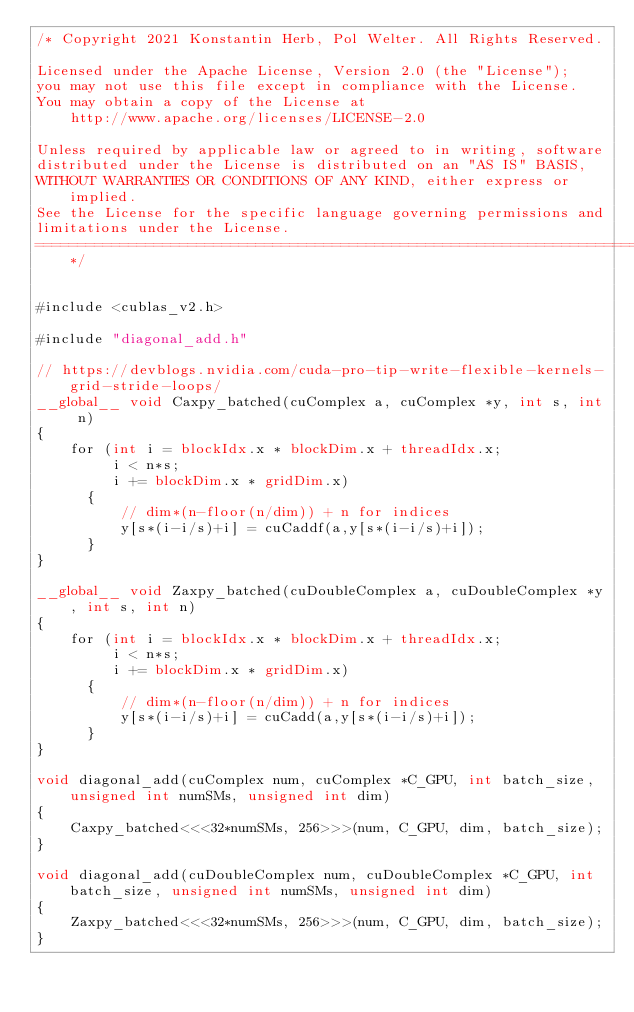Convert code to text. <code><loc_0><loc_0><loc_500><loc_500><_Cuda_>/* Copyright 2021 Konstantin Herb, Pol Welter. All Rights Reserved.

Licensed under the Apache License, Version 2.0 (the "License");
you may not use this file except in compliance with the License.
You may obtain a copy of the License at
    http://www.apache.org/licenses/LICENSE-2.0

Unless required by applicable law or agreed to in writing, software
distributed under the License is distributed on an "AS IS" BASIS,
WITHOUT WARRANTIES OR CONDITIONS OF ANY KIND, either express or implied.
See the License for the specific language governing permissions and
limitations under the License.
==============================================================================*/


#include <cublas_v2.h>

#include "diagonal_add.h"

// https://devblogs.nvidia.com/cuda-pro-tip-write-flexible-kernels-grid-stride-loops/
__global__ void Caxpy_batched(cuComplex a, cuComplex *y, int s, int n)
{
    for (int i = blockIdx.x * blockDim.x + threadIdx.x; 
         i < n*s; 
         i += blockDim.x * gridDim.x) 
      {
          // dim*(n-floor(n/dim)) + n for indices
          y[s*(i-i/s)+i] = cuCaddf(a,y[s*(i-i/s)+i]);
      }
}

__global__ void Zaxpy_batched(cuDoubleComplex a, cuDoubleComplex *y, int s, int n)
{
    for (int i = blockIdx.x * blockDim.x + threadIdx.x; 
         i < n*s; 
         i += blockDim.x * gridDim.x) 
      {
          // dim*(n-floor(n/dim)) + n for indices
          y[s*(i-i/s)+i] = cuCadd(a,y[s*(i-i/s)+i]);
      }
}

void diagonal_add(cuComplex num, cuComplex *C_GPU, int batch_size, unsigned int numSMs, unsigned int dim)
{
    Caxpy_batched<<<32*numSMs, 256>>>(num, C_GPU, dim, batch_size);
}

void diagonal_add(cuDoubleComplex num, cuDoubleComplex *C_GPU, int batch_size, unsigned int numSMs, unsigned int dim)
{
    Zaxpy_batched<<<32*numSMs, 256>>>(num, C_GPU, dim, batch_size);
}
</code> 